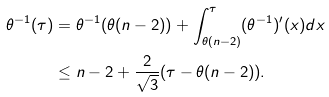<formula> <loc_0><loc_0><loc_500><loc_500>\theta ^ { - 1 } ( \tau ) & = \theta ^ { - 1 } ( \theta ( n - 2 ) ) + \int _ { \theta ( n - 2 ) } ^ { \tau } ( \theta ^ { - 1 } ) ^ { \prime } ( x ) d x \\ & \leq n - 2 + \frac { 2 } { \sqrt { 3 } } ( \tau - \theta ( n - 2 ) ) .</formula> 